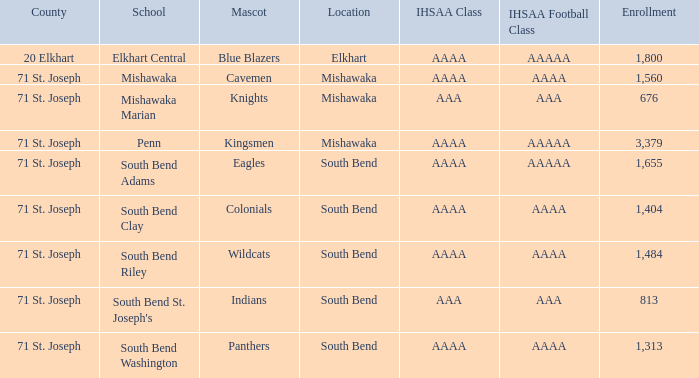I'm looking to parse the entire table for insights. Could you assist me with that? {'header': ['County', 'School', 'Mascot', 'Location', 'IHSAA Class', 'IHSAA Football Class', 'Enrollment'], 'rows': [['20 Elkhart', 'Elkhart Central', 'Blue Blazers', 'Elkhart', 'AAAA', 'AAAAA', '1,800'], ['71 St. Joseph', 'Mishawaka', 'Cavemen', 'Mishawaka', 'AAAA', 'AAAA', '1,560'], ['71 St. Joseph', 'Mishawaka Marian', 'Knights', 'Mishawaka', 'AAA', 'AAA', '676'], ['71 St. Joseph', 'Penn', 'Kingsmen', 'Mishawaka', 'AAAA', 'AAAAA', '3,379'], ['71 St. Joseph', 'South Bend Adams', 'Eagles', 'South Bend', 'AAAA', 'AAAAA', '1,655'], ['71 St. Joseph', 'South Bend Clay', 'Colonials', 'South Bend', 'AAAA', 'AAAA', '1,404'], ['71 St. Joseph', 'South Bend Riley', 'Wildcats', 'South Bend', 'AAAA', 'AAAA', '1,484'], ['71 St. Joseph', "South Bend St. Joseph's", 'Indians', 'South Bend', 'AAA', 'AAA', '813'], ['71 St. Joseph', 'South Bend Washington', 'Panthers', 'South Bend', 'AAAA', 'AAAA', '1,313']]} What IHSAA Football Class has 20 elkhart as the county? AAAAA. 